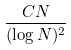<formula> <loc_0><loc_0><loc_500><loc_500>\frac { C N } { ( \log N ) ^ { 2 } }</formula> 